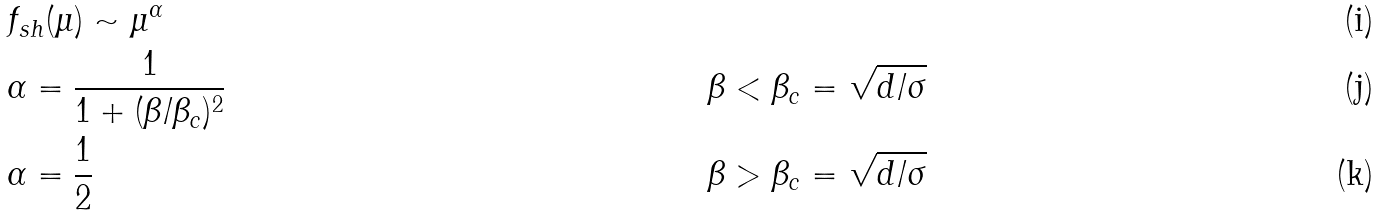Convert formula to latex. <formula><loc_0><loc_0><loc_500><loc_500>& f _ { s h } ( \mu ) \sim \mu ^ { \alpha } \\ & \alpha = \frac { 1 } { 1 + ( \beta / \beta _ { c } ) ^ { 2 } } \quad & & \beta < \beta _ { c } = \sqrt { d / \sigma } \\ & \alpha = \frac { 1 } { 2 } \quad & & \beta > \beta _ { c } = \sqrt { d / \sigma }</formula> 